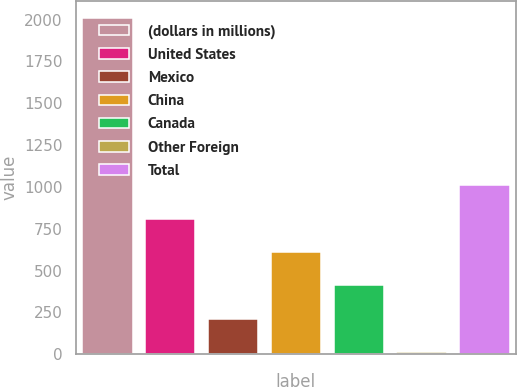Convert chart to OTSL. <chart><loc_0><loc_0><loc_500><loc_500><bar_chart><fcel>(dollars in millions)<fcel>United States<fcel>Mexico<fcel>China<fcel>Canada<fcel>Other Foreign<fcel>Total<nl><fcel>2009<fcel>810.26<fcel>210.89<fcel>610.47<fcel>410.68<fcel>11.1<fcel>1010.05<nl></chart> 